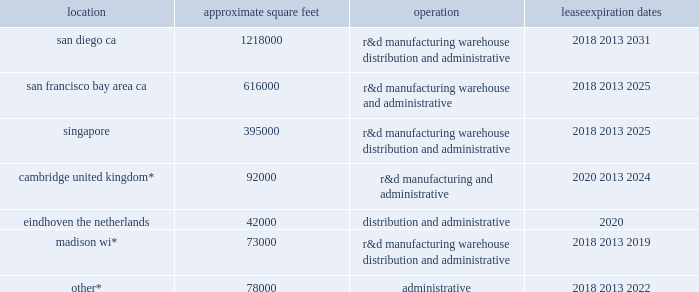Table of contents item 2 .
Properties .
The table summarizes the facilities we lease as of december 31 , 2017 , including the location and size of each principal facility , and their designated use .
We believe our facilities are adequate for our current and near-term needs , and will be able to locate additional facilities as needed .
Location approximate square feet operation expiration dates .
________________ *excludes approximately 309000 square feet for which the leases do not commence until 2018 and beyond .
Item 3 .
Legal proceedings .
We are involved in various lawsuits and claims arising in the ordinary course of business , including actions with respect to intellectual property , employment , and contractual matters .
In connection with these matters , we assess , on a regular basis , the probability and range of possible loss based on the developments in these matters .
A liability is recorded in the financial statements if it is believed to be probable that a loss has been incurred and the amount of the loss can be reasonably estimated .
Because litigation is inherently unpredictable and unfavorable results could occur , assessing contingencies is highly subjective and requires judgments about future events .
We regularly review outstanding legal matters to determine the adequacy of the liabilities accrued and related disclosures .
The amount of ultimate loss may differ from these estimates .
Each matter presents its own unique circumstances , and prior litigation does not necessarily provide a reliable basis on which to predict the outcome , or range of outcomes , in any individual proceeding .
Because of the uncertainties related to the occurrence , amount , and range of loss on any pending litigation or claim , we are currently unable to predict their ultimate outcome , and , with respect to any pending litigation or claim where no liability has been accrued , to make a meaningful estimate of the reasonably possible loss or range of loss that could result from an unfavorable outcome .
In the event opposing litigants in outstanding litigations or claims ultimately succeed at trial and any subsequent appeals on their claims , any potential loss or charges in excess of any established accruals , individually or in the aggregate , could have a material adverse effect on our business , financial condition , results of operations , and/or cash flows in the period in which the unfavorable outcome occurs or becomes probable , and potentially in future periods .
Item 4 .
Mine safety disclosures .
Not applicable. .
As of december 312017 what was the ratio of square footage in san francisco bay area ca singapore? 
Rationale: as of december 312017 the ratio of square footage in san francisco bay area ca singapore was 1.6 to 1
Computations: (616000 / 395000)
Answer: 1.55949. 